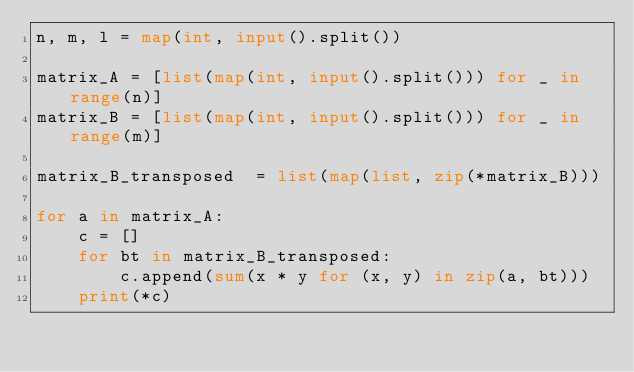<code> <loc_0><loc_0><loc_500><loc_500><_Python_>n, m, l = map(int, input().split())

matrix_A = [list(map(int, input().split())) for _ in range(n)]
matrix_B = [list(map(int, input().split())) for _ in range(m)]

matrix_B_transposed  = list(map(list, zip(*matrix_B)))

for a in matrix_A:
    c = []
    for bt in matrix_B_transposed:
        c.append(sum(x * y for (x, y) in zip(a, bt)))
    print(*c)

</code> 